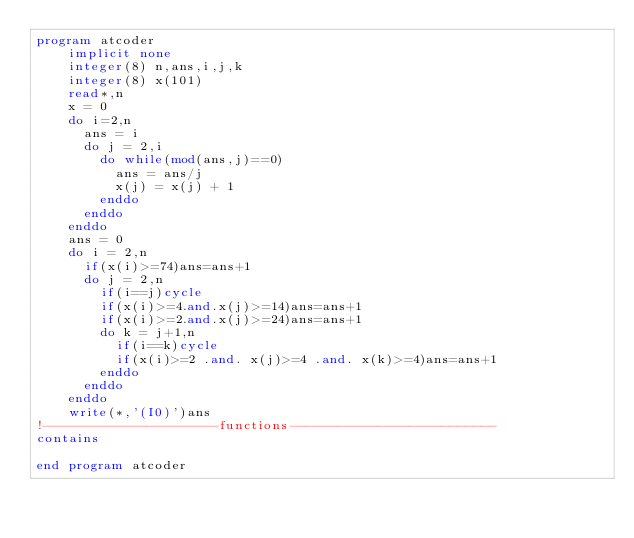Convert code to text. <code><loc_0><loc_0><loc_500><loc_500><_FORTRAN_>program atcoder
    implicit none
    integer(8) n,ans,i,j,k
    integer(8) x(101)
    read*,n
    x = 0
    do i=2,n
      ans = i
      do j = 2,i
        do while(mod(ans,j)==0)
          ans = ans/j
          x(j) = x(j) + 1
        enddo
      enddo
    enddo
    ans = 0
    do i = 2,n
      if(x(i)>=74)ans=ans+1
      do j = 2,n
        if(i==j)cycle
        if(x(i)>=4.and.x(j)>=14)ans=ans+1
        if(x(i)>=2.and.x(j)>=24)ans=ans+1
        do k = j+1,n
          if(i==k)cycle
          if(x(i)>=2 .and. x(j)>=4 .and. x(k)>=4)ans=ans+1
        enddo
      enddo
    enddo
    write(*,'(I0)')ans
!----------------------functions--------------------------
contains

end program atcoder</code> 